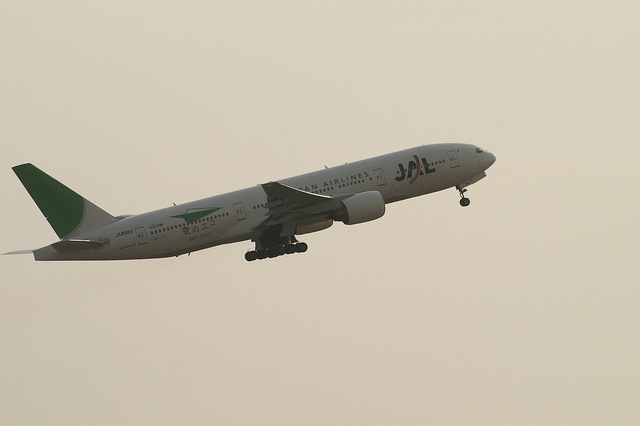Describe the objects in this image and their specific colors. I can see a airplane in lightgray, gray, black, and darkgreen tones in this image. 